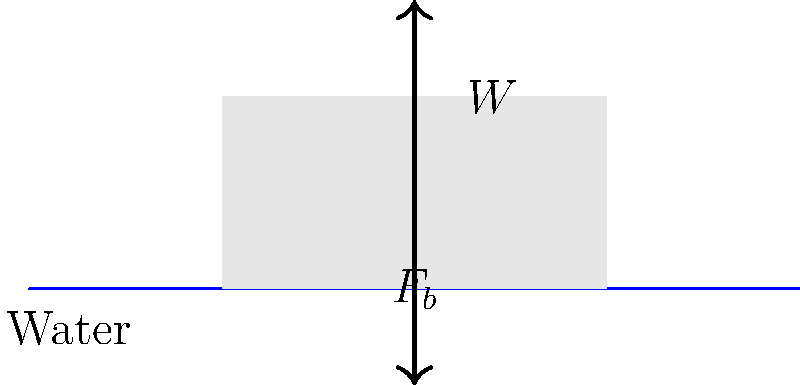A rectangular buoy used for monitoring water quality in Lake Michigan is floating as shown in the free-body diagram. If the buoy has a weight (W) of 500 N, what is the magnitude of the buoyancy force ($F_b$) acting on it? To solve this problem, we need to understand the principle of buoyancy and the conditions for a floating object. Let's approach this step-by-step:

1. Recall that for an object to float, it must be in equilibrium. This means that the net force acting on the object must be zero.

2. In this case, there are two forces acting on the buoy:
   a. The weight (W) acting downward
   b. The buoyancy force ($F_b$) acting upward

3. For the buoy to be in equilibrium:
   $F_b - W = 0$

4. Rearranging this equation:
   $F_b = W$

5. We are given that the weight of the buoy is 500 N. Therefore:
   $F_b = 500$ N

This result aligns with Archimedes' principle, which states that the buoyancy force on a submerged or floating object is equal to the weight of the fluid displaced by the object. In the case of a floating object, the weight of the displaced fluid is equal to the weight of the object.
Answer: $F_b = 500$ N 